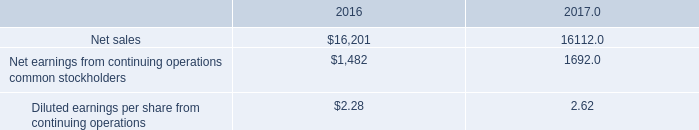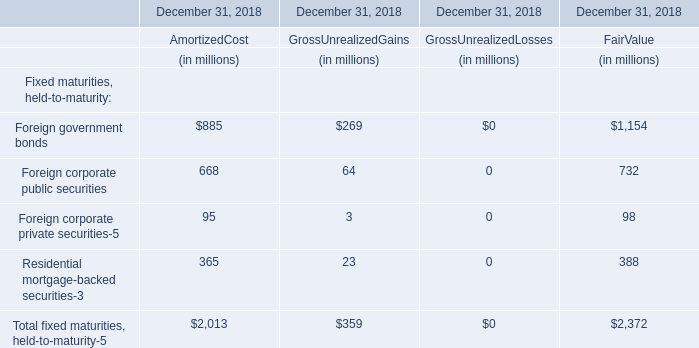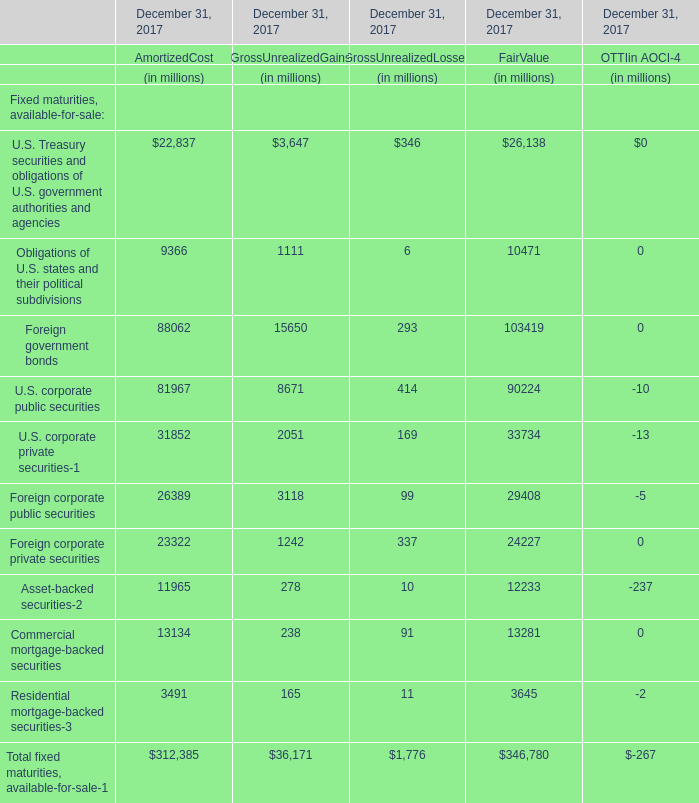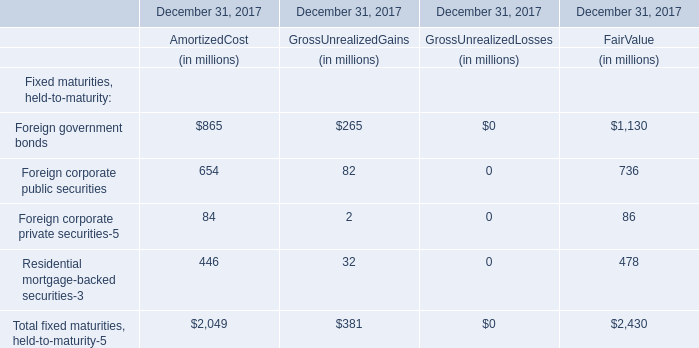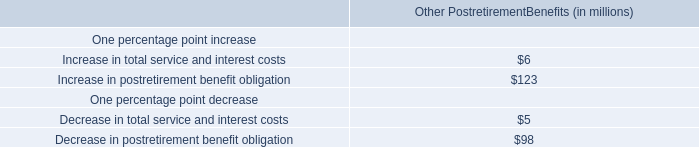How much of Gross Unrealized Gains is there in total (in 2017) without Foreign corporate public securities and Foreign corporate private securities-5? (in million) 
Computations: (265 + 32)
Answer: 297.0. 